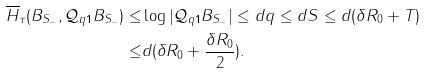Convert formula to latex. <formula><loc_0><loc_0><loc_500><loc_500>\overline { H } _ { \tau } ( B _ { S _ { - } } , \mathcal { Q } _ { q \mathbf 1 } B _ { S _ { - } } ) \leq & \log | \mathcal { Q } _ { q \mathbf 1 } B _ { S _ { - } } | \leq d q \leq d S \leq d ( \delta R _ { 0 } + T ) \\ \leq & d ( \delta R _ { 0 } + \frac { \delta R _ { 0 } } 2 ) .</formula> 